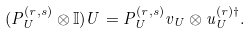<formula> <loc_0><loc_0><loc_500><loc_500>( P _ { U } ^ { ( r , s ) } \otimes \mathbb { I } ) U = P _ { U } ^ { ( r , s ) } v _ { U } \otimes u _ { U } ^ { ( r ) \dag } .</formula> 